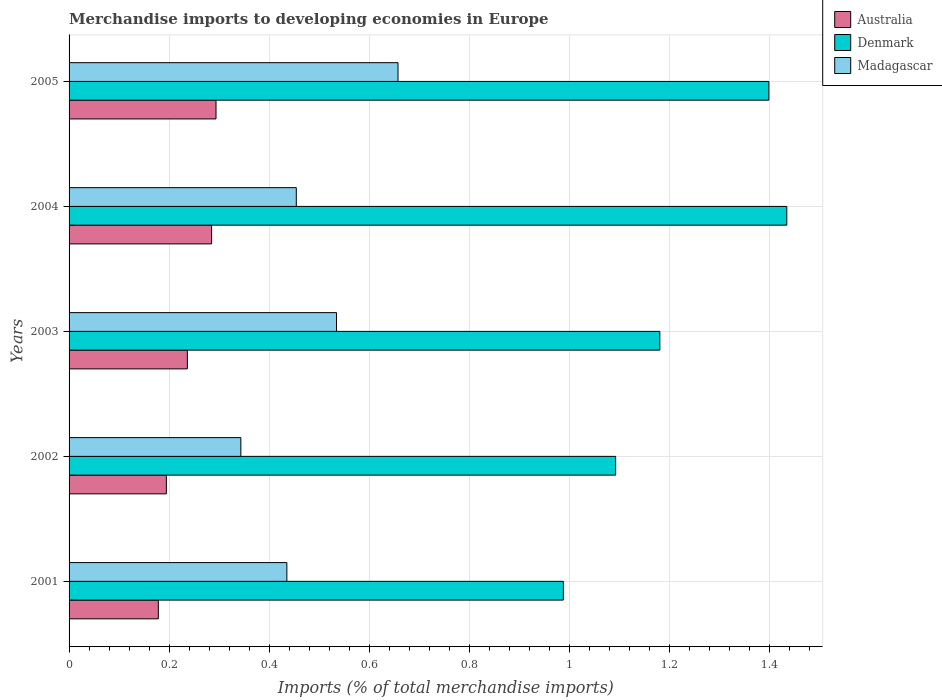How many different coloured bars are there?
Ensure brevity in your answer.  3. Are the number of bars on each tick of the Y-axis equal?
Make the answer very short. Yes. How many bars are there on the 5th tick from the top?
Your answer should be very brief. 3. What is the percentage total merchandise imports in Denmark in 2003?
Ensure brevity in your answer.  1.18. Across all years, what is the maximum percentage total merchandise imports in Denmark?
Offer a terse response. 1.43. Across all years, what is the minimum percentage total merchandise imports in Madagascar?
Make the answer very short. 0.34. What is the total percentage total merchandise imports in Australia in the graph?
Make the answer very short. 1.19. What is the difference between the percentage total merchandise imports in Madagascar in 2003 and that in 2004?
Make the answer very short. 0.08. What is the difference between the percentage total merchandise imports in Australia in 2005 and the percentage total merchandise imports in Denmark in 2003?
Give a very brief answer. -0.89. What is the average percentage total merchandise imports in Madagascar per year?
Your answer should be very brief. 0.48. In the year 2001, what is the difference between the percentage total merchandise imports in Madagascar and percentage total merchandise imports in Australia?
Ensure brevity in your answer.  0.26. What is the ratio of the percentage total merchandise imports in Australia in 2001 to that in 2002?
Offer a terse response. 0.92. What is the difference between the highest and the second highest percentage total merchandise imports in Denmark?
Provide a succinct answer. 0.04. What is the difference between the highest and the lowest percentage total merchandise imports in Australia?
Offer a very short reply. 0.12. Is the sum of the percentage total merchandise imports in Madagascar in 2003 and 2004 greater than the maximum percentage total merchandise imports in Australia across all years?
Give a very brief answer. Yes. Is it the case that in every year, the sum of the percentage total merchandise imports in Denmark and percentage total merchandise imports in Madagascar is greater than the percentage total merchandise imports in Australia?
Your answer should be compact. Yes. Are all the bars in the graph horizontal?
Keep it short and to the point. Yes. How many years are there in the graph?
Offer a terse response. 5. Does the graph contain grids?
Keep it short and to the point. Yes. How many legend labels are there?
Provide a short and direct response. 3. What is the title of the graph?
Give a very brief answer. Merchandise imports to developing economies in Europe. What is the label or title of the X-axis?
Your response must be concise. Imports (% of total merchandise imports). What is the label or title of the Y-axis?
Provide a short and direct response. Years. What is the Imports (% of total merchandise imports) in Australia in 2001?
Give a very brief answer. 0.18. What is the Imports (% of total merchandise imports) of Denmark in 2001?
Provide a short and direct response. 0.99. What is the Imports (% of total merchandise imports) in Madagascar in 2001?
Make the answer very short. 0.44. What is the Imports (% of total merchandise imports) of Australia in 2002?
Provide a succinct answer. 0.19. What is the Imports (% of total merchandise imports) of Denmark in 2002?
Give a very brief answer. 1.09. What is the Imports (% of total merchandise imports) in Madagascar in 2002?
Offer a terse response. 0.34. What is the Imports (% of total merchandise imports) of Australia in 2003?
Provide a succinct answer. 0.24. What is the Imports (% of total merchandise imports) of Denmark in 2003?
Offer a terse response. 1.18. What is the Imports (% of total merchandise imports) of Madagascar in 2003?
Offer a terse response. 0.53. What is the Imports (% of total merchandise imports) in Australia in 2004?
Keep it short and to the point. 0.28. What is the Imports (% of total merchandise imports) of Denmark in 2004?
Provide a succinct answer. 1.43. What is the Imports (% of total merchandise imports) of Madagascar in 2004?
Your answer should be compact. 0.45. What is the Imports (% of total merchandise imports) in Australia in 2005?
Give a very brief answer. 0.29. What is the Imports (% of total merchandise imports) in Denmark in 2005?
Keep it short and to the point. 1.4. What is the Imports (% of total merchandise imports) in Madagascar in 2005?
Provide a short and direct response. 0.66. Across all years, what is the maximum Imports (% of total merchandise imports) of Australia?
Keep it short and to the point. 0.29. Across all years, what is the maximum Imports (% of total merchandise imports) of Denmark?
Keep it short and to the point. 1.43. Across all years, what is the maximum Imports (% of total merchandise imports) in Madagascar?
Provide a short and direct response. 0.66. Across all years, what is the minimum Imports (% of total merchandise imports) in Australia?
Make the answer very short. 0.18. Across all years, what is the minimum Imports (% of total merchandise imports) in Denmark?
Your answer should be compact. 0.99. Across all years, what is the minimum Imports (% of total merchandise imports) in Madagascar?
Offer a very short reply. 0.34. What is the total Imports (% of total merchandise imports) of Australia in the graph?
Your answer should be very brief. 1.19. What is the total Imports (% of total merchandise imports) in Denmark in the graph?
Your response must be concise. 6.09. What is the total Imports (% of total merchandise imports) of Madagascar in the graph?
Provide a succinct answer. 2.42. What is the difference between the Imports (% of total merchandise imports) of Australia in 2001 and that in 2002?
Your answer should be very brief. -0.02. What is the difference between the Imports (% of total merchandise imports) of Denmark in 2001 and that in 2002?
Offer a very short reply. -0.1. What is the difference between the Imports (% of total merchandise imports) of Madagascar in 2001 and that in 2002?
Make the answer very short. 0.09. What is the difference between the Imports (% of total merchandise imports) of Australia in 2001 and that in 2003?
Your answer should be very brief. -0.06. What is the difference between the Imports (% of total merchandise imports) of Denmark in 2001 and that in 2003?
Your answer should be compact. -0.19. What is the difference between the Imports (% of total merchandise imports) in Madagascar in 2001 and that in 2003?
Offer a very short reply. -0.1. What is the difference between the Imports (% of total merchandise imports) in Australia in 2001 and that in 2004?
Your answer should be very brief. -0.11. What is the difference between the Imports (% of total merchandise imports) of Denmark in 2001 and that in 2004?
Make the answer very short. -0.45. What is the difference between the Imports (% of total merchandise imports) in Madagascar in 2001 and that in 2004?
Your answer should be very brief. -0.02. What is the difference between the Imports (% of total merchandise imports) of Australia in 2001 and that in 2005?
Your answer should be very brief. -0.12. What is the difference between the Imports (% of total merchandise imports) in Denmark in 2001 and that in 2005?
Keep it short and to the point. -0.41. What is the difference between the Imports (% of total merchandise imports) of Madagascar in 2001 and that in 2005?
Provide a succinct answer. -0.22. What is the difference between the Imports (% of total merchandise imports) in Australia in 2002 and that in 2003?
Offer a very short reply. -0.04. What is the difference between the Imports (% of total merchandise imports) of Denmark in 2002 and that in 2003?
Ensure brevity in your answer.  -0.09. What is the difference between the Imports (% of total merchandise imports) in Madagascar in 2002 and that in 2003?
Your response must be concise. -0.19. What is the difference between the Imports (% of total merchandise imports) in Australia in 2002 and that in 2004?
Your answer should be very brief. -0.09. What is the difference between the Imports (% of total merchandise imports) in Denmark in 2002 and that in 2004?
Provide a short and direct response. -0.34. What is the difference between the Imports (% of total merchandise imports) in Madagascar in 2002 and that in 2004?
Your answer should be very brief. -0.11. What is the difference between the Imports (% of total merchandise imports) of Australia in 2002 and that in 2005?
Offer a terse response. -0.1. What is the difference between the Imports (% of total merchandise imports) of Denmark in 2002 and that in 2005?
Give a very brief answer. -0.31. What is the difference between the Imports (% of total merchandise imports) in Madagascar in 2002 and that in 2005?
Your answer should be very brief. -0.31. What is the difference between the Imports (% of total merchandise imports) in Australia in 2003 and that in 2004?
Offer a very short reply. -0.05. What is the difference between the Imports (% of total merchandise imports) in Denmark in 2003 and that in 2004?
Give a very brief answer. -0.25. What is the difference between the Imports (% of total merchandise imports) in Madagascar in 2003 and that in 2004?
Offer a terse response. 0.08. What is the difference between the Imports (% of total merchandise imports) of Australia in 2003 and that in 2005?
Offer a very short reply. -0.06. What is the difference between the Imports (% of total merchandise imports) of Denmark in 2003 and that in 2005?
Your answer should be compact. -0.22. What is the difference between the Imports (% of total merchandise imports) of Madagascar in 2003 and that in 2005?
Offer a very short reply. -0.12. What is the difference between the Imports (% of total merchandise imports) of Australia in 2004 and that in 2005?
Provide a succinct answer. -0.01. What is the difference between the Imports (% of total merchandise imports) of Denmark in 2004 and that in 2005?
Your answer should be compact. 0.04. What is the difference between the Imports (% of total merchandise imports) of Madagascar in 2004 and that in 2005?
Your answer should be compact. -0.2. What is the difference between the Imports (% of total merchandise imports) of Australia in 2001 and the Imports (% of total merchandise imports) of Denmark in 2002?
Your answer should be very brief. -0.91. What is the difference between the Imports (% of total merchandise imports) of Australia in 2001 and the Imports (% of total merchandise imports) of Madagascar in 2002?
Offer a terse response. -0.16. What is the difference between the Imports (% of total merchandise imports) in Denmark in 2001 and the Imports (% of total merchandise imports) in Madagascar in 2002?
Give a very brief answer. 0.64. What is the difference between the Imports (% of total merchandise imports) in Australia in 2001 and the Imports (% of total merchandise imports) in Denmark in 2003?
Make the answer very short. -1. What is the difference between the Imports (% of total merchandise imports) in Australia in 2001 and the Imports (% of total merchandise imports) in Madagascar in 2003?
Your answer should be compact. -0.36. What is the difference between the Imports (% of total merchandise imports) in Denmark in 2001 and the Imports (% of total merchandise imports) in Madagascar in 2003?
Offer a very short reply. 0.45. What is the difference between the Imports (% of total merchandise imports) in Australia in 2001 and the Imports (% of total merchandise imports) in Denmark in 2004?
Give a very brief answer. -1.26. What is the difference between the Imports (% of total merchandise imports) of Australia in 2001 and the Imports (% of total merchandise imports) of Madagascar in 2004?
Your answer should be very brief. -0.28. What is the difference between the Imports (% of total merchandise imports) of Denmark in 2001 and the Imports (% of total merchandise imports) of Madagascar in 2004?
Offer a very short reply. 0.53. What is the difference between the Imports (% of total merchandise imports) in Australia in 2001 and the Imports (% of total merchandise imports) in Denmark in 2005?
Ensure brevity in your answer.  -1.22. What is the difference between the Imports (% of total merchandise imports) of Australia in 2001 and the Imports (% of total merchandise imports) of Madagascar in 2005?
Your answer should be very brief. -0.48. What is the difference between the Imports (% of total merchandise imports) in Denmark in 2001 and the Imports (% of total merchandise imports) in Madagascar in 2005?
Give a very brief answer. 0.33. What is the difference between the Imports (% of total merchandise imports) of Australia in 2002 and the Imports (% of total merchandise imports) of Denmark in 2003?
Offer a very short reply. -0.99. What is the difference between the Imports (% of total merchandise imports) of Australia in 2002 and the Imports (% of total merchandise imports) of Madagascar in 2003?
Ensure brevity in your answer.  -0.34. What is the difference between the Imports (% of total merchandise imports) in Denmark in 2002 and the Imports (% of total merchandise imports) in Madagascar in 2003?
Keep it short and to the point. 0.56. What is the difference between the Imports (% of total merchandise imports) of Australia in 2002 and the Imports (% of total merchandise imports) of Denmark in 2004?
Your answer should be very brief. -1.24. What is the difference between the Imports (% of total merchandise imports) in Australia in 2002 and the Imports (% of total merchandise imports) in Madagascar in 2004?
Your answer should be compact. -0.26. What is the difference between the Imports (% of total merchandise imports) in Denmark in 2002 and the Imports (% of total merchandise imports) in Madagascar in 2004?
Keep it short and to the point. 0.64. What is the difference between the Imports (% of total merchandise imports) of Australia in 2002 and the Imports (% of total merchandise imports) of Denmark in 2005?
Your answer should be compact. -1.2. What is the difference between the Imports (% of total merchandise imports) in Australia in 2002 and the Imports (% of total merchandise imports) in Madagascar in 2005?
Offer a very short reply. -0.46. What is the difference between the Imports (% of total merchandise imports) in Denmark in 2002 and the Imports (% of total merchandise imports) in Madagascar in 2005?
Offer a terse response. 0.43. What is the difference between the Imports (% of total merchandise imports) of Australia in 2003 and the Imports (% of total merchandise imports) of Denmark in 2004?
Give a very brief answer. -1.2. What is the difference between the Imports (% of total merchandise imports) in Australia in 2003 and the Imports (% of total merchandise imports) in Madagascar in 2004?
Offer a terse response. -0.22. What is the difference between the Imports (% of total merchandise imports) of Denmark in 2003 and the Imports (% of total merchandise imports) of Madagascar in 2004?
Provide a short and direct response. 0.73. What is the difference between the Imports (% of total merchandise imports) of Australia in 2003 and the Imports (% of total merchandise imports) of Denmark in 2005?
Offer a very short reply. -1.16. What is the difference between the Imports (% of total merchandise imports) in Australia in 2003 and the Imports (% of total merchandise imports) in Madagascar in 2005?
Your response must be concise. -0.42. What is the difference between the Imports (% of total merchandise imports) in Denmark in 2003 and the Imports (% of total merchandise imports) in Madagascar in 2005?
Make the answer very short. 0.52. What is the difference between the Imports (% of total merchandise imports) in Australia in 2004 and the Imports (% of total merchandise imports) in Denmark in 2005?
Your response must be concise. -1.11. What is the difference between the Imports (% of total merchandise imports) in Australia in 2004 and the Imports (% of total merchandise imports) in Madagascar in 2005?
Keep it short and to the point. -0.37. What is the difference between the Imports (% of total merchandise imports) in Denmark in 2004 and the Imports (% of total merchandise imports) in Madagascar in 2005?
Ensure brevity in your answer.  0.78. What is the average Imports (% of total merchandise imports) of Australia per year?
Your answer should be very brief. 0.24. What is the average Imports (% of total merchandise imports) of Denmark per year?
Your response must be concise. 1.22. What is the average Imports (% of total merchandise imports) in Madagascar per year?
Your response must be concise. 0.48. In the year 2001, what is the difference between the Imports (% of total merchandise imports) of Australia and Imports (% of total merchandise imports) of Denmark?
Make the answer very short. -0.81. In the year 2001, what is the difference between the Imports (% of total merchandise imports) in Australia and Imports (% of total merchandise imports) in Madagascar?
Your answer should be very brief. -0.26. In the year 2001, what is the difference between the Imports (% of total merchandise imports) of Denmark and Imports (% of total merchandise imports) of Madagascar?
Offer a very short reply. 0.55. In the year 2002, what is the difference between the Imports (% of total merchandise imports) in Australia and Imports (% of total merchandise imports) in Denmark?
Your response must be concise. -0.9. In the year 2002, what is the difference between the Imports (% of total merchandise imports) of Australia and Imports (% of total merchandise imports) of Madagascar?
Your response must be concise. -0.15. In the year 2002, what is the difference between the Imports (% of total merchandise imports) of Denmark and Imports (% of total merchandise imports) of Madagascar?
Your answer should be very brief. 0.75. In the year 2003, what is the difference between the Imports (% of total merchandise imports) in Australia and Imports (% of total merchandise imports) in Denmark?
Your answer should be compact. -0.94. In the year 2003, what is the difference between the Imports (% of total merchandise imports) of Australia and Imports (% of total merchandise imports) of Madagascar?
Offer a terse response. -0.3. In the year 2003, what is the difference between the Imports (% of total merchandise imports) in Denmark and Imports (% of total merchandise imports) in Madagascar?
Ensure brevity in your answer.  0.65. In the year 2004, what is the difference between the Imports (% of total merchandise imports) of Australia and Imports (% of total merchandise imports) of Denmark?
Ensure brevity in your answer.  -1.15. In the year 2004, what is the difference between the Imports (% of total merchandise imports) of Australia and Imports (% of total merchandise imports) of Madagascar?
Your response must be concise. -0.17. In the year 2005, what is the difference between the Imports (% of total merchandise imports) of Australia and Imports (% of total merchandise imports) of Denmark?
Your answer should be very brief. -1.1. In the year 2005, what is the difference between the Imports (% of total merchandise imports) of Australia and Imports (% of total merchandise imports) of Madagascar?
Your answer should be compact. -0.36. In the year 2005, what is the difference between the Imports (% of total merchandise imports) in Denmark and Imports (% of total merchandise imports) in Madagascar?
Ensure brevity in your answer.  0.74. What is the ratio of the Imports (% of total merchandise imports) in Australia in 2001 to that in 2002?
Keep it short and to the point. 0.92. What is the ratio of the Imports (% of total merchandise imports) in Denmark in 2001 to that in 2002?
Your response must be concise. 0.9. What is the ratio of the Imports (% of total merchandise imports) of Madagascar in 2001 to that in 2002?
Your answer should be compact. 1.27. What is the ratio of the Imports (% of total merchandise imports) in Australia in 2001 to that in 2003?
Keep it short and to the point. 0.75. What is the ratio of the Imports (% of total merchandise imports) of Denmark in 2001 to that in 2003?
Ensure brevity in your answer.  0.84. What is the ratio of the Imports (% of total merchandise imports) of Madagascar in 2001 to that in 2003?
Offer a very short reply. 0.81. What is the ratio of the Imports (% of total merchandise imports) of Australia in 2001 to that in 2004?
Your response must be concise. 0.63. What is the ratio of the Imports (% of total merchandise imports) in Denmark in 2001 to that in 2004?
Offer a very short reply. 0.69. What is the ratio of the Imports (% of total merchandise imports) of Madagascar in 2001 to that in 2004?
Your answer should be compact. 0.96. What is the ratio of the Imports (% of total merchandise imports) in Australia in 2001 to that in 2005?
Offer a very short reply. 0.61. What is the ratio of the Imports (% of total merchandise imports) in Denmark in 2001 to that in 2005?
Offer a very short reply. 0.71. What is the ratio of the Imports (% of total merchandise imports) of Madagascar in 2001 to that in 2005?
Provide a short and direct response. 0.66. What is the ratio of the Imports (% of total merchandise imports) of Australia in 2002 to that in 2003?
Offer a very short reply. 0.82. What is the ratio of the Imports (% of total merchandise imports) in Denmark in 2002 to that in 2003?
Your answer should be very brief. 0.93. What is the ratio of the Imports (% of total merchandise imports) in Madagascar in 2002 to that in 2003?
Give a very brief answer. 0.64. What is the ratio of the Imports (% of total merchandise imports) of Australia in 2002 to that in 2004?
Provide a succinct answer. 0.68. What is the ratio of the Imports (% of total merchandise imports) in Denmark in 2002 to that in 2004?
Ensure brevity in your answer.  0.76. What is the ratio of the Imports (% of total merchandise imports) of Madagascar in 2002 to that in 2004?
Provide a short and direct response. 0.76. What is the ratio of the Imports (% of total merchandise imports) of Australia in 2002 to that in 2005?
Provide a short and direct response. 0.66. What is the ratio of the Imports (% of total merchandise imports) in Denmark in 2002 to that in 2005?
Your answer should be very brief. 0.78. What is the ratio of the Imports (% of total merchandise imports) in Madagascar in 2002 to that in 2005?
Your answer should be very brief. 0.52. What is the ratio of the Imports (% of total merchandise imports) in Australia in 2003 to that in 2004?
Your answer should be very brief. 0.83. What is the ratio of the Imports (% of total merchandise imports) of Denmark in 2003 to that in 2004?
Offer a very short reply. 0.82. What is the ratio of the Imports (% of total merchandise imports) of Madagascar in 2003 to that in 2004?
Your answer should be very brief. 1.18. What is the ratio of the Imports (% of total merchandise imports) of Australia in 2003 to that in 2005?
Offer a very short reply. 0.8. What is the ratio of the Imports (% of total merchandise imports) of Denmark in 2003 to that in 2005?
Give a very brief answer. 0.84. What is the ratio of the Imports (% of total merchandise imports) in Madagascar in 2003 to that in 2005?
Ensure brevity in your answer.  0.81. What is the ratio of the Imports (% of total merchandise imports) in Australia in 2004 to that in 2005?
Make the answer very short. 0.97. What is the ratio of the Imports (% of total merchandise imports) of Denmark in 2004 to that in 2005?
Offer a terse response. 1.03. What is the ratio of the Imports (% of total merchandise imports) in Madagascar in 2004 to that in 2005?
Keep it short and to the point. 0.69. What is the difference between the highest and the second highest Imports (% of total merchandise imports) of Australia?
Keep it short and to the point. 0.01. What is the difference between the highest and the second highest Imports (% of total merchandise imports) in Denmark?
Give a very brief answer. 0.04. What is the difference between the highest and the second highest Imports (% of total merchandise imports) of Madagascar?
Provide a succinct answer. 0.12. What is the difference between the highest and the lowest Imports (% of total merchandise imports) in Australia?
Make the answer very short. 0.12. What is the difference between the highest and the lowest Imports (% of total merchandise imports) in Denmark?
Your answer should be very brief. 0.45. What is the difference between the highest and the lowest Imports (% of total merchandise imports) in Madagascar?
Your response must be concise. 0.31. 